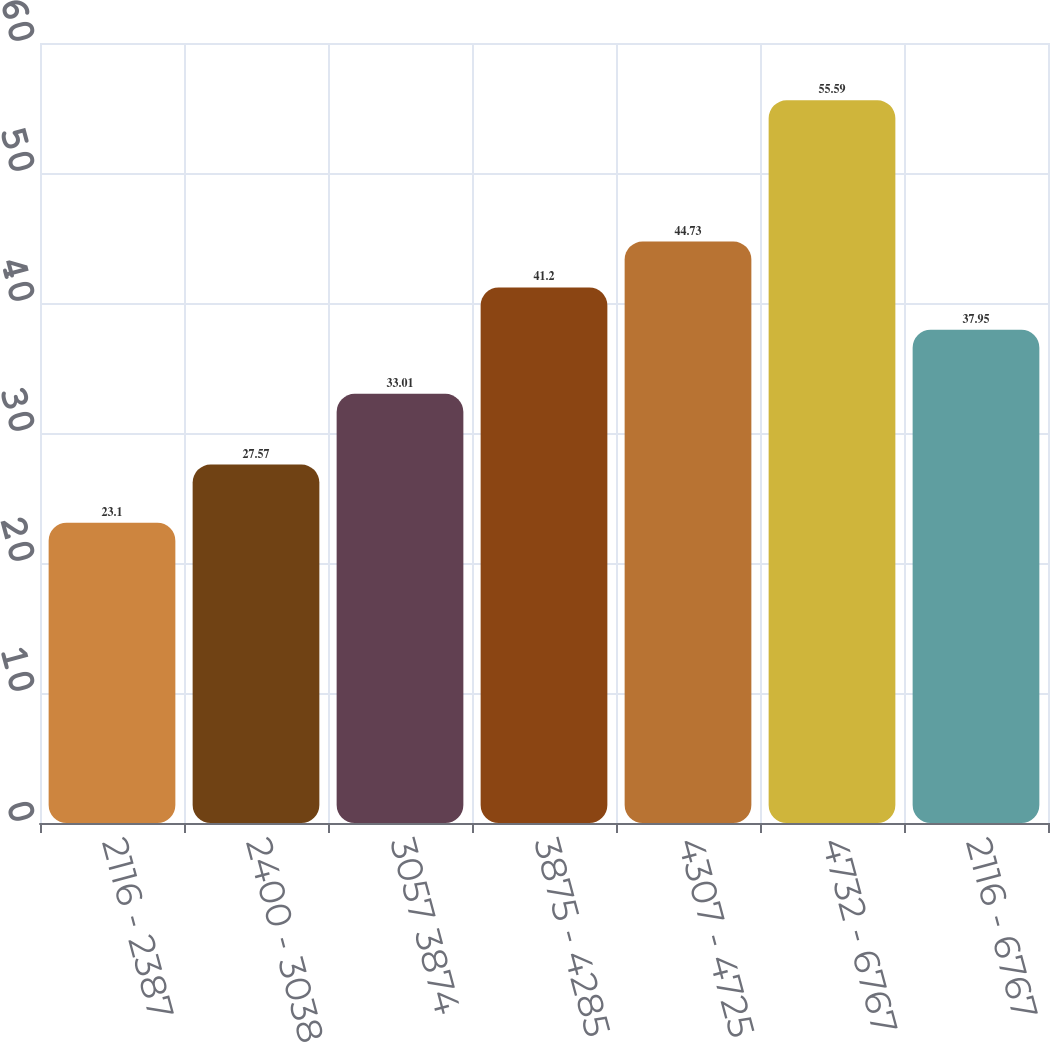Convert chart. <chart><loc_0><loc_0><loc_500><loc_500><bar_chart><fcel>2116 - 2387<fcel>2400 - 3038 -<fcel>3057 3874<fcel>3875 - 4285<fcel>4307 - 4725<fcel>4732 - 6767<fcel>2116 - 6767<nl><fcel>23.1<fcel>27.57<fcel>33.01<fcel>41.2<fcel>44.73<fcel>55.59<fcel>37.95<nl></chart> 